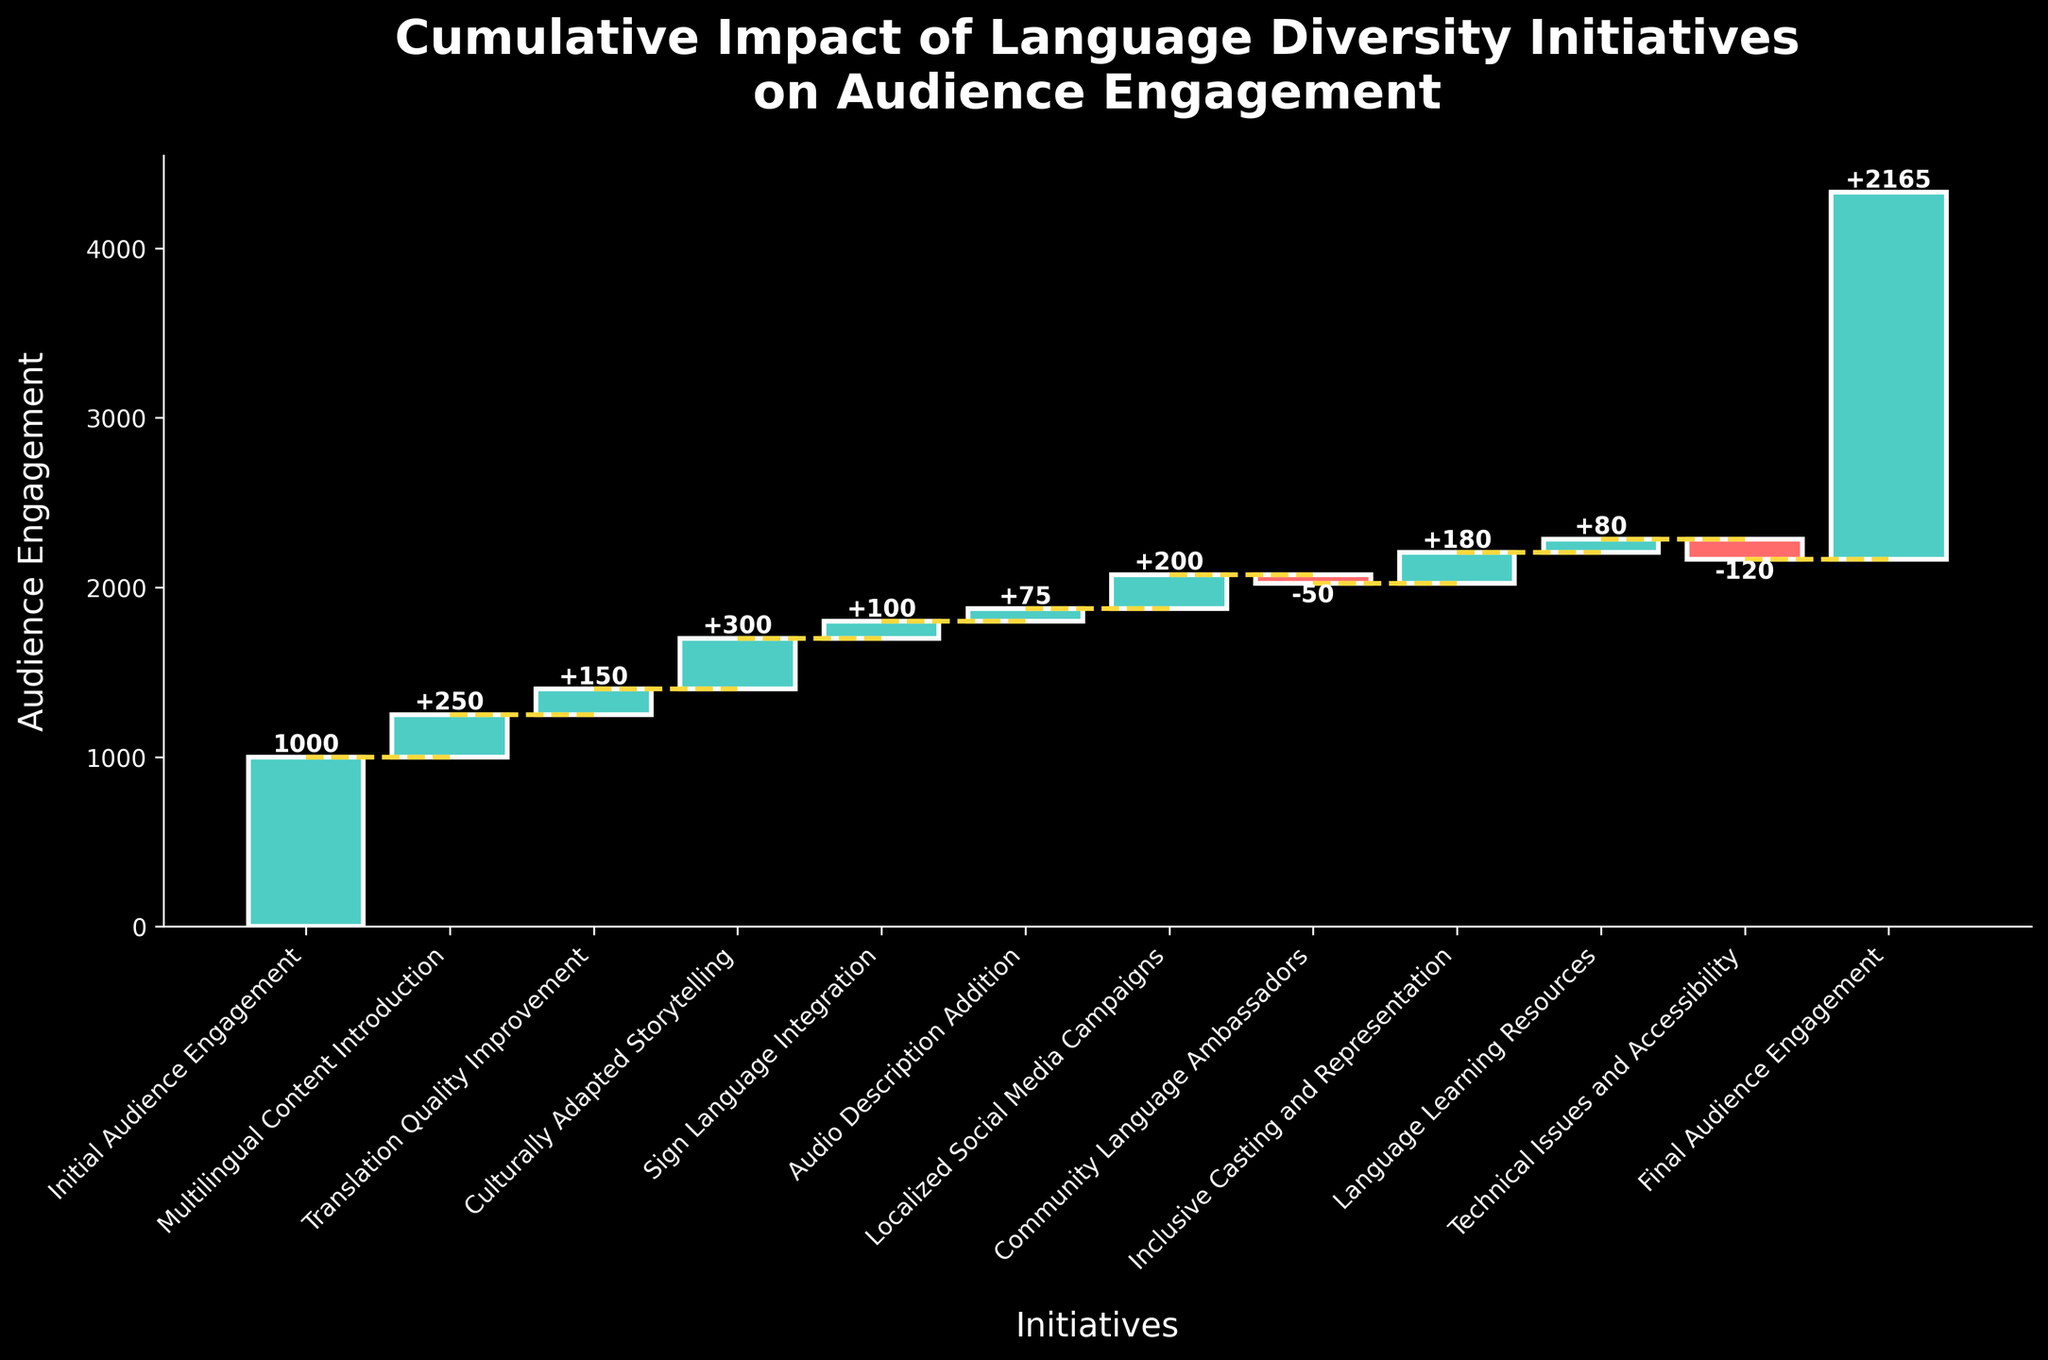What is the title of the chart? The title is located at the top of the chart and describes the overall theme of the data being presented.
Answer: Cumulative Impact of Language Diversity Initiatives on Audience Engagement What was the initial audience engagement value? The first category in the chart is labeled "Initial Audience Engagement," and its value is indicated.
Answer: 1000 How many initiatives positively impacted the audience engagement? Count the number of categories with positive values added to the baseline cumulative line in the waterfall chart.
Answer: 8 Which initiative had the highest positive impact on audience engagement? Identify the category with the largest bar above the baseline cumulative line in the chart.
Answer: Culturally Adapted Storytelling What was the cumulative audience engagement after sign language integration? Add the initial audience engagement and the values from the subsequent categories up to and including Sign Language Integration.
Answer: 1000 + 250 + 150 + 300 + 100 = 1800 How did community language ambassadors affect the audience engagement? Look at the bar corresponding to "Community Language Ambassadors" and identify whether its value is positive or negative.
Answer: Decreased it by 50 Compare the impact of translation quality improvement and localized social media campaigns. Check the heights of bars corresponding to these initiatives and see which one is taller. Translation Quality Improvement adds +150, while Localized Social Media Campaigns adds +200.
Answer: Localized Social Media Campaigns had a higher impact What is the cumulative effect of all positive initiatives? Sum up all the positive contributions. These are +250, +150, +300, +100, +75, +200, +180, +80.
Answer: 1335 How does the impact of technical issues and accessibility compare to the impact of inclusive casting and representation? Compare the values of these two categories. Technical Issues and Accessibility decreased by 120, while Inclusive Casting and Representation increased by 180.
Answer: Inclusive Casting and Representation had a greater positive impact 